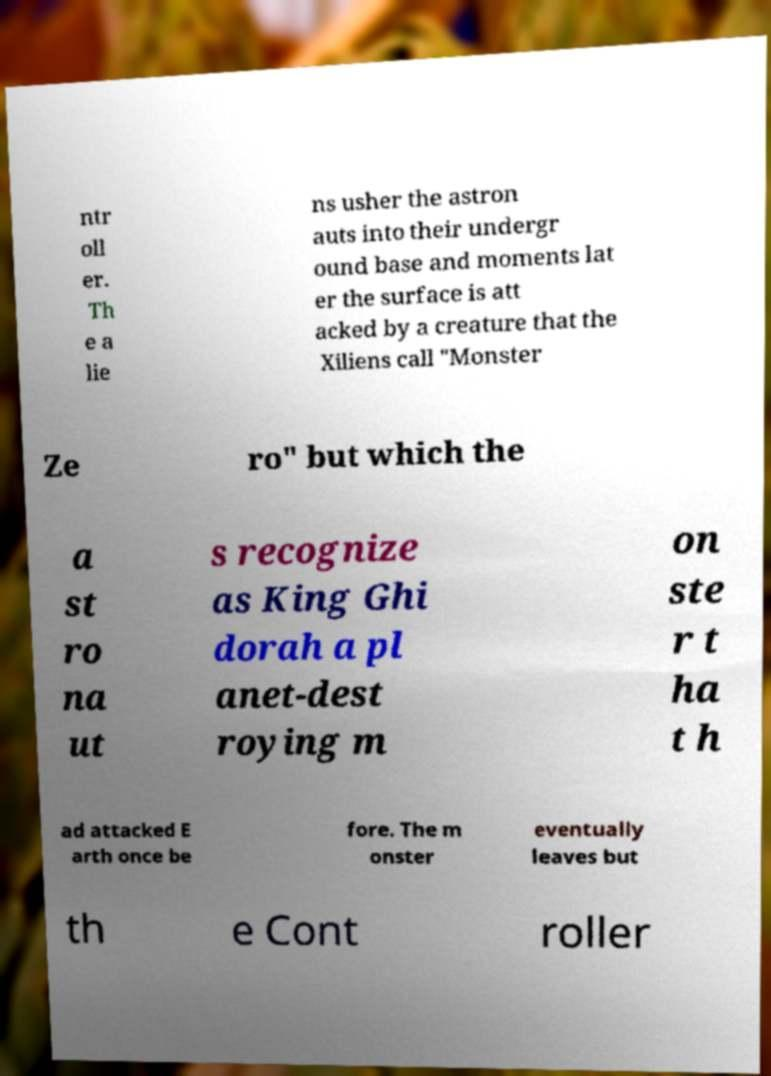There's text embedded in this image that I need extracted. Can you transcribe it verbatim? ntr oll er. Th e a lie ns usher the astron auts into their undergr ound base and moments lat er the surface is att acked by a creature that the Xiliens call "Monster Ze ro" but which the a st ro na ut s recognize as King Ghi dorah a pl anet-dest roying m on ste r t ha t h ad attacked E arth once be fore. The m onster eventually leaves but th e Cont roller 